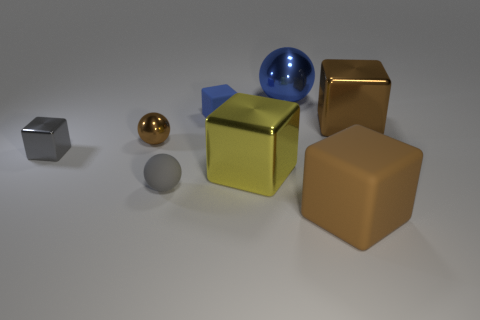What number of other blocks are the same color as the large matte block?
Your answer should be compact. 1. What material is the brown ball behind the tiny matte thing on the left side of the small rubber thing behind the gray block made of?
Your answer should be compact. Metal. There is a small block that is on the right side of the small sphere behind the gray rubber sphere; what is its color?
Your answer should be very brief. Blue. How many big objects are yellow shiny objects or brown shiny spheres?
Offer a very short reply. 1. What number of yellow objects are the same material as the small brown sphere?
Keep it short and to the point. 1. There is a rubber object that is on the left side of the tiny blue thing; how big is it?
Offer a terse response. Small. What is the shape of the large object that is behind the rubber thing behind the gray shiny object?
Offer a terse response. Sphere. There is a blue ball that is to the right of the matte cube left of the blue metal sphere; what number of rubber objects are on the right side of it?
Your response must be concise. 1. Are there fewer large metal spheres in front of the gray metal thing than tiny brown things?
Keep it short and to the point. Yes. Is there anything else that is the same shape as the brown rubber thing?
Keep it short and to the point. Yes. 